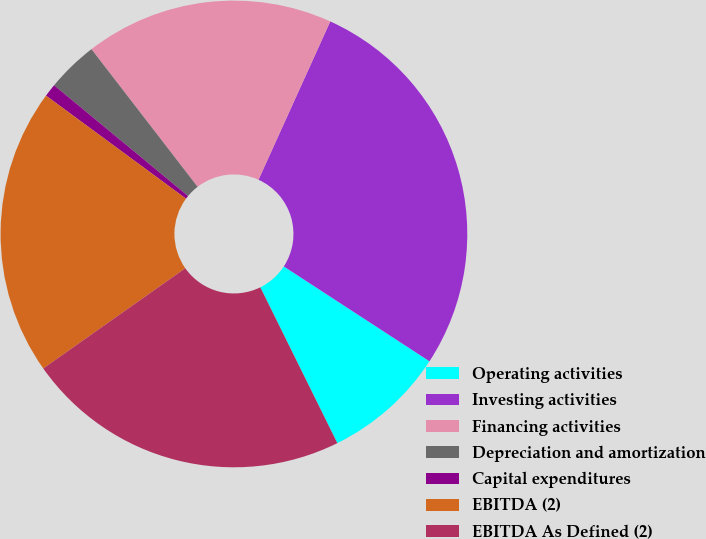Convert chart. <chart><loc_0><loc_0><loc_500><loc_500><pie_chart><fcel>Operating activities<fcel>Investing activities<fcel>Financing activities<fcel>Depreciation and amortization<fcel>Capital expenditures<fcel>EBITDA (2)<fcel>EBITDA As Defined (2)<nl><fcel>8.51%<fcel>27.42%<fcel>17.23%<fcel>3.55%<fcel>0.9%<fcel>19.88%<fcel>22.53%<nl></chart> 